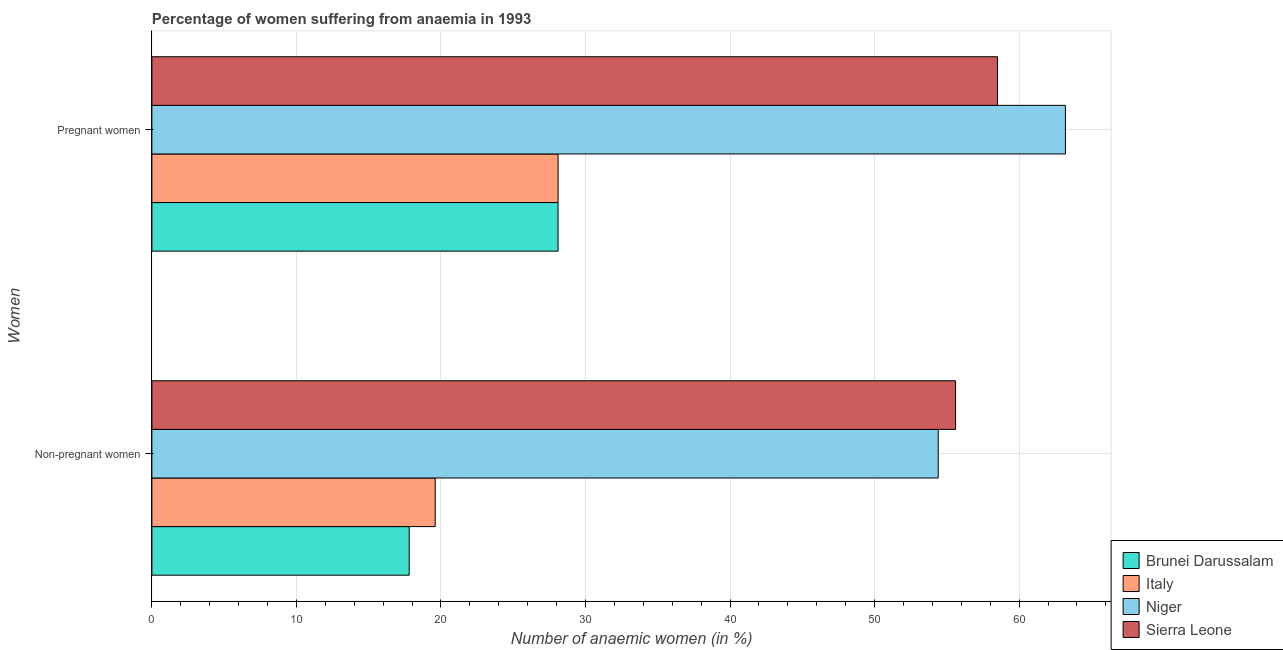Are the number of bars on each tick of the Y-axis equal?
Your answer should be compact. Yes. How many bars are there on the 1st tick from the bottom?
Ensure brevity in your answer.  4. What is the label of the 1st group of bars from the top?
Your answer should be very brief. Pregnant women. What is the percentage of pregnant anaemic women in Sierra Leone?
Your answer should be very brief. 58.5. Across all countries, what is the maximum percentage of pregnant anaemic women?
Your answer should be very brief. 63.2. Across all countries, what is the minimum percentage of non-pregnant anaemic women?
Provide a short and direct response. 17.8. In which country was the percentage of non-pregnant anaemic women maximum?
Keep it short and to the point. Sierra Leone. In which country was the percentage of pregnant anaemic women minimum?
Provide a short and direct response. Brunei Darussalam. What is the total percentage of non-pregnant anaemic women in the graph?
Ensure brevity in your answer.  147.4. What is the difference between the percentage of pregnant anaemic women in Sierra Leone and that in Italy?
Keep it short and to the point. 30.4. What is the difference between the percentage of pregnant anaemic women in Brunei Darussalam and the percentage of non-pregnant anaemic women in Italy?
Make the answer very short. 8.5. What is the average percentage of pregnant anaemic women per country?
Make the answer very short. 44.48. What is the difference between the percentage of pregnant anaemic women and percentage of non-pregnant anaemic women in Niger?
Provide a succinct answer. 8.8. What is the ratio of the percentage of pregnant anaemic women in Italy to that in Brunei Darussalam?
Provide a succinct answer. 1. What does the 4th bar from the top in Non-pregnant women represents?
Offer a terse response. Brunei Darussalam. What does the 3rd bar from the bottom in Pregnant women represents?
Ensure brevity in your answer.  Niger. How many bars are there?
Give a very brief answer. 8. Are all the bars in the graph horizontal?
Give a very brief answer. Yes. What is the difference between two consecutive major ticks on the X-axis?
Your response must be concise. 10. Are the values on the major ticks of X-axis written in scientific E-notation?
Give a very brief answer. No. Does the graph contain any zero values?
Your answer should be compact. No. Does the graph contain grids?
Provide a short and direct response. Yes. How many legend labels are there?
Offer a very short reply. 4. How are the legend labels stacked?
Your answer should be compact. Vertical. What is the title of the graph?
Offer a terse response. Percentage of women suffering from anaemia in 1993. What is the label or title of the X-axis?
Ensure brevity in your answer.  Number of anaemic women (in %). What is the label or title of the Y-axis?
Ensure brevity in your answer.  Women. What is the Number of anaemic women (in %) in Italy in Non-pregnant women?
Offer a very short reply. 19.6. What is the Number of anaemic women (in %) of Niger in Non-pregnant women?
Your answer should be very brief. 54.4. What is the Number of anaemic women (in %) in Sierra Leone in Non-pregnant women?
Provide a short and direct response. 55.6. What is the Number of anaemic women (in %) in Brunei Darussalam in Pregnant women?
Offer a terse response. 28.1. What is the Number of anaemic women (in %) in Italy in Pregnant women?
Offer a very short reply. 28.1. What is the Number of anaemic women (in %) in Niger in Pregnant women?
Your response must be concise. 63.2. What is the Number of anaemic women (in %) of Sierra Leone in Pregnant women?
Ensure brevity in your answer.  58.5. Across all Women, what is the maximum Number of anaemic women (in %) of Brunei Darussalam?
Give a very brief answer. 28.1. Across all Women, what is the maximum Number of anaemic women (in %) in Italy?
Offer a terse response. 28.1. Across all Women, what is the maximum Number of anaemic women (in %) in Niger?
Your answer should be compact. 63.2. Across all Women, what is the maximum Number of anaemic women (in %) in Sierra Leone?
Your answer should be very brief. 58.5. Across all Women, what is the minimum Number of anaemic women (in %) in Brunei Darussalam?
Give a very brief answer. 17.8. Across all Women, what is the minimum Number of anaemic women (in %) in Italy?
Keep it short and to the point. 19.6. Across all Women, what is the minimum Number of anaemic women (in %) in Niger?
Your response must be concise. 54.4. Across all Women, what is the minimum Number of anaemic women (in %) of Sierra Leone?
Offer a terse response. 55.6. What is the total Number of anaemic women (in %) of Brunei Darussalam in the graph?
Ensure brevity in your answer.  45.9. What is the total Number of anaemic women (in %) of Italy in the graph?
Give a very brief answer. 47.7. What is the total Number of anaemic women (in %) in Niger in the graph?
Make the answer very short. 117.6. What is the total Number of anaemic women (in %) in Sierra Leone in the graph?
Offer a terse response. 114.1. What is the difference between the Number of anaemic women (in %) of Brunei Darussalam in Non-pregnant women and that in Pregnant women?
Your answer should be compact. -10.3. What is the difference between the Number of anaemic women (in %) in Italy in Non-pregnant women and that in Pregnant women?
Ensure brevity in your answer.  -8.5. What is the difference between the Number of anaemic women (in %) of Niger in Non-pregnant women and that in Pregnant women?
Your response must be concise. -8.8. What is the difference between the Number of anaemic women (in %) of Brunei Darussalam in Non-pregnant women and the Number of anaemic women (in %) of Niger in Pregnant women?
Provide a succinct answer. -45.4. What is the difference between the Number of anaemic women (in %) of Brunei Darussalam in Non-pregnant women and the Number of anaemic women (in %) of Sierra Leone in Pregnant women?
Give a very brief answer. -40.7. What is the difference between the Number of anaemic women (in %) of Italy in Non-pregnant women and the Number of anaemic women (in %) of Niger in Pregnant women?
Offer a very short reply. -43.6. What is the difference between the Number of anaemic women (in %) in Italy in Non-pregnant women and the Number of anaemic women (in %) in Sierra Leone in Pregnant women?
Your answer should be very brief. -38.9. What is the difference between the Number of anaemic women (in %) of Niger in Non-pregnant women and the Number of anaemic women (in %) of Sierra Leone in Pregnant women?
Keep it short and to the point. -4.1. What is the average Number of anaemic women (in %) of Brunei Darussalam per Women?
Offer a terse response. 22.95. What is the average Number of anaemic women (in %) of Italy per Women?
Your answer should be very brief. 23.85. What is the average Number of anaemic women (in %) in Niger per Women?
Offer a very short reply. 58.8. What is the average Number of anaemic women (in %) in Sierra Leone per Women?
Offer a very short reply. 57.05. What is the difference between the Number of anaemic women (in %) of Brunei Darussalam and Number of anaemic women (in %) of Niger in Non-pregnant women?
Make the answer very short. -36.6. What is the difference between the Number of anaemic women (in %) in Brunei Darussalam and Number of anaemic women (in %) in Sierra Leone in Non-pregnant women?
Your answer should be compact. -37.8. What is the difference between the Number of anaemic women (in %) in Italy and Number of anaemic women (in %) in Niger in Non-pregnant women?
Your answer should be very brief. -34.8. What is the difference between the Number of anaemic women (in %) of Italy and Number of anaemic women (in %) of Sierra Leone in Non-pregnant women?
Ensure brevity in your answer.  -36. What is the difference between the Number of anaemic women (in %) in Brunei Darussalam and Number of anaemic women (in %) in Niger in Pregnant women?
Your response must be concise. -35.1. What is the difference between the Number of anaemic women (in %) of Brunei Darussalam and Number of anaemic women (in %) of Sierra Leone in Pregnant women?
Give a very brief answer. -30.4. What is the difference between the Number of anaemic women (in %) of Italy and Number of anaemic women (in %) of Niger in Pregnant women?
Offer a terse response. -35.1. What is the difference between the Number of anaemic women (in %) in Italy and Number of anaemic women (in %) in Sierra Leone in Pregnant women?
Make the answer very short. -30.4. What is the ratio of the Number of anaemic women (in %) of Brunei Darussalam in Non-pregnant women to that in Pregnant women?
Provide a succinct answer. 0.63. What is the ratio of the Number of anaemic women (in %) of Italy in Non-pregnant women to that in Pregnant women?
Your answer should be compact. 0.7. What is the ratio of the Number of anaemic women (in %) of Niger in Non-pregnant women to that in Pregnant women?
Offer a terse response. 0.86. What is the ratio of the Number of anaemic women (in %) of Sierra Leone in Non-pregnant women to that in Pregnant women?
Offer a very short reply. 0.95. What is the difference between the highest and the second highest Number of anaemic women (in %) of Italy?
Provide a short and direct response. 8.5. What is the difference between the highest and the second highest Number of anaemic women (in %) of Niger?
Offer a terse response. 8.8. What is the difference between the highest and the lowest Number of anaemic women (in %) of Niger?
Your answer should be compact. 8.8. What is the difference between the highest and the lowest Number of anaemic women (in %) of Sierra Leone?
Offer a terse response. 2.9. 